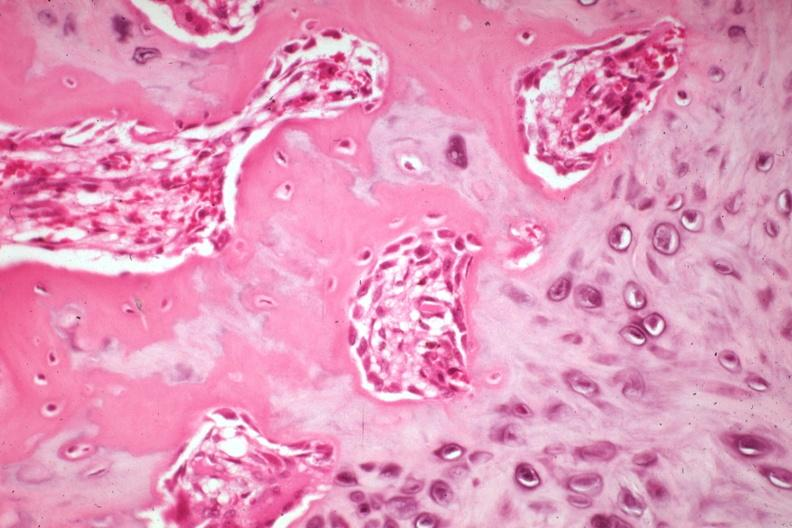s excellent example case a non-union?
Answer the question using a single word or phrase. Yes 